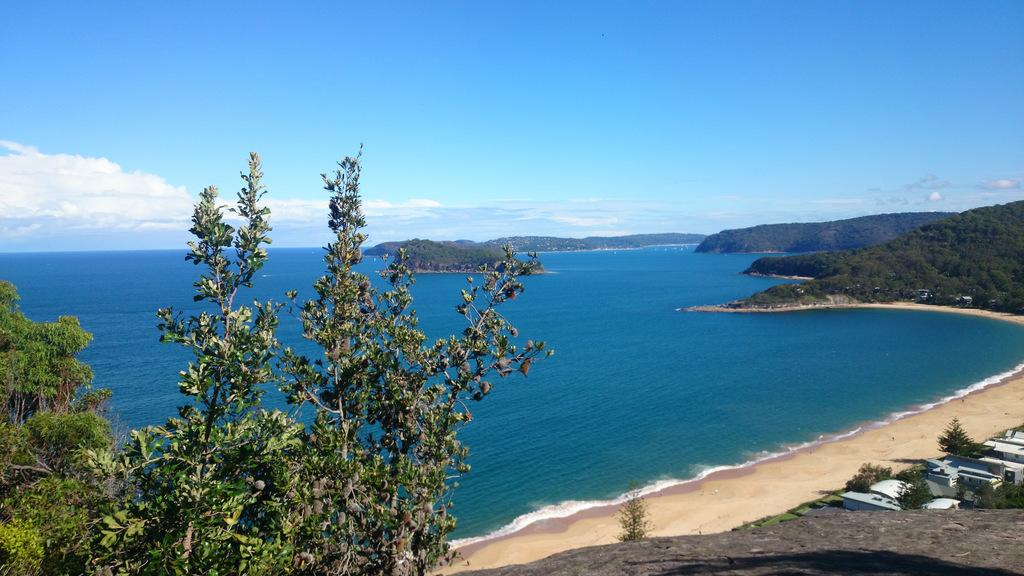What is the primary element in the image? There is water in the image. What type of vegetation can be seen in the image? There are trees in the image. What structures are located on the right side of the image? There are buildings on the right side of the image. What is visible in the background of the image? The sky is visible in the background of the image. What can be observed in the sky? Clouds are present in the sky. Can you describe the patch of fur on the kitten in the image? There is no kitten present in the image, so we cannot describe any fur or patches. 